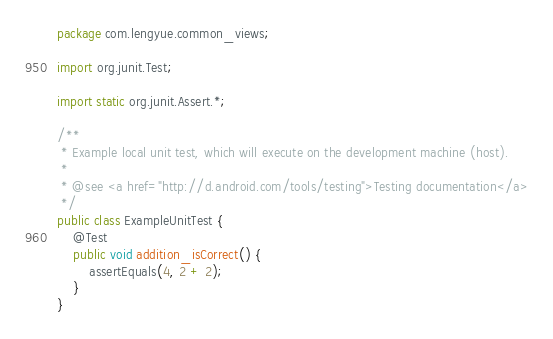Convert code to text. <code><loc_0><loc_0><loc_500><loc_500><_Java_>package com.lengyue.common_views;

import org.junit.Test;

import static org.junit.Assert.*;

/**
 * Example local unit test, which will execute on the development machine (host).
 *
 * @see <a href="http://d.android.com/tools/testing">Testing documentation</a>
 */
public class ExampleUnitTest {
    @Test
    public void addition_isCorrect() {
        assertEquals(4, 2 + 2);
    }
}</code> 